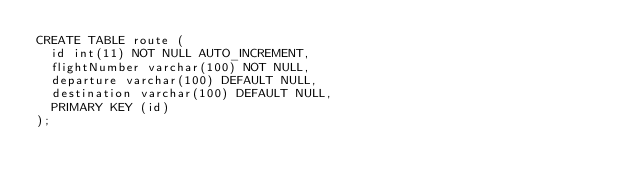Convert code to text. <code><loc_0><loc_0><loc_500><loc_500><_SQL_>CREATE TABLE route (
  id int(11) NOT NULL AUTO_INCREMENT,
  flightNumber varchar(100) NOT NULL,
  departure varchar(100) DEFAULT NULL,
  destination varchar(100) DEFAULT NULL,
  PRIMARY KEY (id)
);</code> 